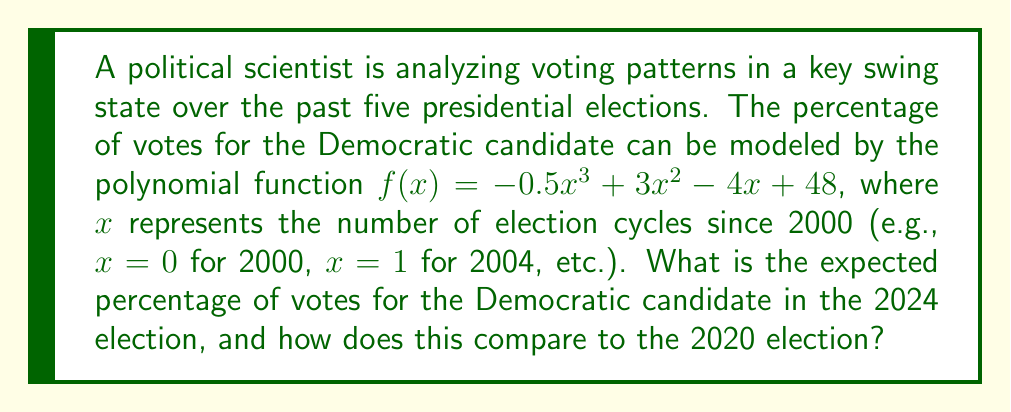Teach me how to tackle this problem. To solve this problem, we need to follow these steps:

1) First, we need to determine the $x$ values for 2020 and 2024:
   - 2020 is 5 election cycles after 2000, so $x_2020 = 5$
   - 2024 is 6 election cycles after 2000, so $x_2024 = 6$

2) Now, let's calculate the percentage for 2020 ($x = 5$):
   $f(5) = -0.5(5^3) + 3(5^2) - 4(5) + 48$
   $= -0.5(125) + 3(25) - 20 + 48$
   $= -62.5 + 75 - 20 + 48$
   $= 40.5\%$

3) Next, let's calculate the percentage for 2024 ($x = 6$):
   $f(6) = -0.5(6^3) + 3(6^2) - 4(6) + 48$
   $= -0.5(216) + 3(36) - 24 + 48$
   $= -108 + 108 - 24 + 48$
   $= 24\%$

4) To compare:
   The model predicts a decrease from 40.5% in 2020 to 24% in 2024, a drop of 16.5 percentage points.
Answer: 24%; 16.5 percentage point decrease from 2020 